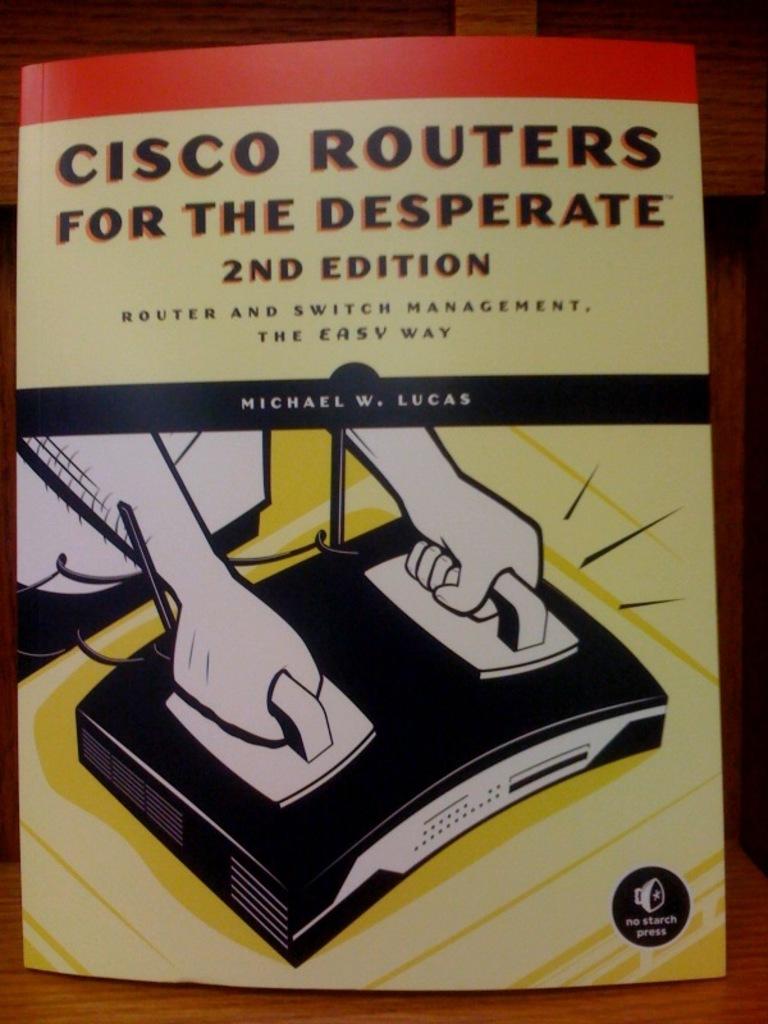Which edition is this book?
Provide a succinct answer. 2nd. Who wrote this book?
Offer a very short reply. Michael w. lucas. 